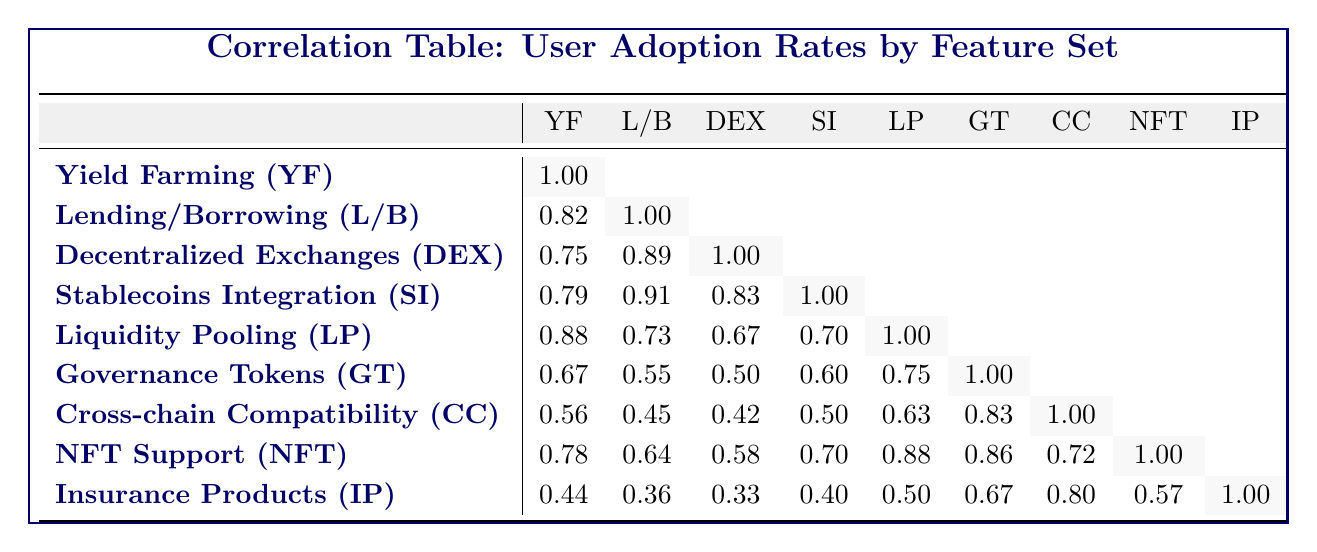What is the adoption rate for Decentralized Exchanges? The table shows the adoption rate for Decentralized Exchanges (DEX) under its corresponding feature name in the row. The adoption rate for DEX is directly provided as 60.
Answer: 60 Which feature set has the highest adoption rate? By comparing the adoption rates listed in the table, we find that the highest value is 60, which corresponds to Decentralized Exchanges (DEX).
Answer: Decentralized Exchanges (DEX) Is the adoption rate for Governance Tokens higher than that for Cross-chain Compatibility? Looking at the adoption rates, Governance Tokens has an adoption rate of 30 while Cross-chain Compatibility has a rate of 25. Since 30 is greater than 25, the statement is true.
Answer: Yes What is the average adoption rate of Liquid Pooling and Insurance Products? The adoption rate for Liquidity Pooling is 40 and for Insurance Products is 20. To find the average, we sum these two rates: 40 + 20 = 60, and then divide by 2: 60 / 2 = 30.
Answer: 30 If a user adopts Stablecoins Integration, what is the correlation with Yield Farming? In the table, the correlation between Stablecoins Integration and Yield Farming is given as 0.79. This suggests there is a strong relationship between the adoption of these two features.
Answer: 0.79 Which two feature sets have the closest adoption rates? By examining the adoption rates, Lending/Borrowing and Stablecoins Integration have rates of 55 and 50 respectively. Their difference is 5, which is the smallest when compared to other pairs.
Answer: Lending/Borrowing and Stablecoins Integration What percentage increase in adoption rate is observed when moving from Insurance Products to NFT Support? The adoption rate for Insurance Products is 20 and for NFT Support is 35. The difference is 35 - 20 = 15. To find the percentage increase, we calculate (15 / 20) * 100 = 75%.
Answer: 75% Does Cross-chain Compatibility show a higher adoption rate than Governance Tokens? Cross-chain Compatibility has an adoption rate of 25, and Governance Tokens has an adoption rate of 30. Since 25 is less than 30, the statement is false.
Answer: No Which feature has the lowest adoption rate, and what is that rate? By looking at the table, we see that Insurance Products has the lowest adoption rate of all listed features at 20.
Answer: 20 